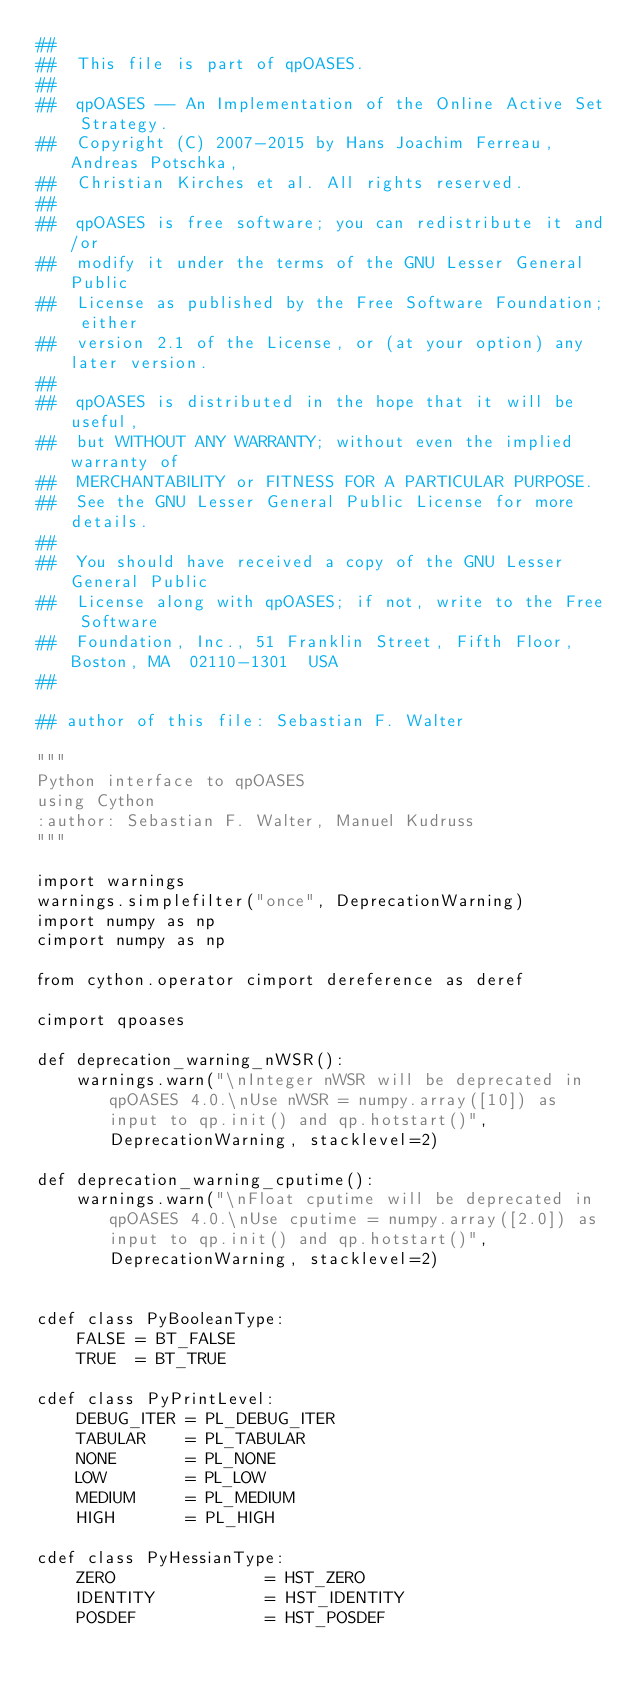<code> <loc_0><loc_0><loc_500><loc_500><_Cython_>##
##  This file is part of qpOASES.
##
##  qpOASES -- An Implementation of the Online Active Set Strategy.
##  Copyright (C) 2007-2015 by Hans Joachim Ferreau, Andreas Potschka,
##  Christian Kirches et al. All rights reserved.
##
##  qpOASES is free software; you can redistribute it and/or
##  modify it under the terms of the GNU Lesser General Public
##  License as published by the Free Software Foundation; either
##  version 2.1 of the License, or (at your option) any later version.
##
##  qpOASES is distributed in the hope that it will be useful,
##  but WITHOUT ANY WARRANTY; without even the implied warranty of
##  MERCHANTABILITY or FITNESS FOR A PARTICULAR PURPOSE.
##  See the GNU Lesser General Public License for more details.
##
##  You should have received a copy of the GNU Lesser General Public
##  License along with qpOASES; if not, write to the Free Software
##  Foundation, Inc., 51 Franklin Street, Fifth Floor, Boston, MA  02110-1301  USA
##

## author of this file: Sebastian F. Walter

"""
Python interface to qpOASES
using Cython
:author: Sebastian F. Walter, Manuel Kudruss
"""

import warnings
warnings.simplefilter("once", DeprecationWarning)
import numpy as np
cimport numpy as np

from cython.operator cimport dereference as deref

cimport qpoases

def deprecation_warning_nWSR():
    warnings.warn("\nInteger nWSR will be deprecated in qpOASES 4.0.\nUse nWSR = numpy.array([10]) as input to qp.init() and qp.hotstart()", DeprecationWarning, stacklevel=2)

def deprecation_warning_cputime():
    warnings.warn("\nFloat cputime will be deprecated in qpOASES 4.0.\nUse cputime = numpy.array([2.0]) as input to qp.init() and qp.hotstart()", DeprecationWarning, stacklevel=2)


cdef class PyBooleanType:
    FALSE = BT_FALSE
    TRUE  = BT_TRUE

cdef class PyPrintLevel:
    DEBUG_ITER = PL_DEBUG_ITER
    TABULAR    = PL_TABULAR
    NONE       = PL_NONE
    LOW        = PL_LOW
    MEDIUM     = PL_MEDIUM
    HIGH       = PL_HIGH

cdef class PyHessianType:
    ZERO               = HST_ZERO
    IDENTITY           = HST_IDENTITY
    POSDEF             = HST_POSDEF</code> 